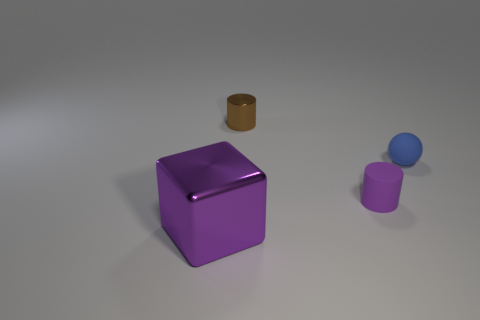Subtract all purple cylinders. How many cylinders are left? 1 Subtract all balls. How many objects are left? 3 Add 2 large red shiny blocks. How many objects exist? 6 Subtract 0 gray blocks. How many objects are left? 4 Subtract all small yellow rubber balls. Subtract all tiny brown shiny cylinders. How many objects are left? 3 Add 1 tiny blue matte objects. How many tiny blue matte objects are left? 2 Add 1 large cyan matte spheres. How many large cyan matte spheres exist? 1 